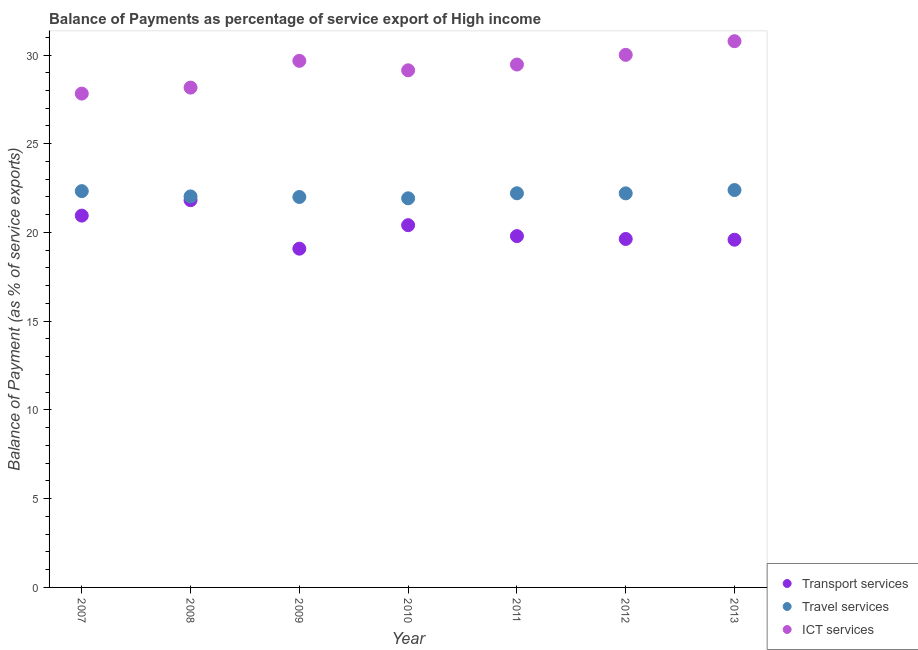Is the number of dotlines equal to the number of legend labels?
Your response must be concise. Yes. What is the balance of payment of travel services in 2008?
Your answer should be very brief. 22.03. Across all years, what is the maximum balance of payment of travel services?
Ensure brevity in your answer.  22.39. Across all years, what is the minimum balance of payment of travel services?
Provide a succinct answer. 21.93. What is the total balance of payment of ict services in the graph?
Offer a very short reply. 205.05. What is the difference between the balance of payment of transport services in 2007 and that in 2008?
Your response must be concise. -0.87. What is the difference between the balance of payment of ict services in 2007 and the balance of payment of travel services in 2013?
Make the answer very short. 5.43. What is the average balance of payment of transport services per year?
Provide a short and direct response. 20.18. In the year 2010, what is the difference between the balance of payment of ict services and balance of payment of travel services?
Provide a short and direct response. 7.21. What is the ratio of the balance of payment of travel services in 2007 to that in 2012?
Your response must be concise. 1.01. What is the difference between the highest and the second highest balance of payment of travel services?
Provide a short and direct response. 0.06. What is the difference between the highest and the lowest balance of payment of ict services?
Give a very brief answer. 2.95. Is the sum of the balance of payment of travel services in 2007 and 2009 greater than the maximum balance of payment of transport services across all years?
Ensure brevity in your answer.  Yes. Does the balance of payment of ict services monotonically increase over the years?
Provide a short and direct response. No. How many dotlines are there?
Provide a succinct answer. 3. How many years are there in the graph?
Make the answer very short. 7. Does the graph contain any zero values?
Keep it short and to the point. No. Does the graph contain grids?
Give a very brief answer. No. How are the legend labels stacked?
Provide a succinct answer. Vertical. What is the title of the graph?
Make the answer very short. Balance of Payments as percentage of service export of High income. What is the label or title of the Y-axis?
Offer a very short reply. Balance of Payment (as % of service exports). What is the Balance of Payment (as % of service exports) of Transport services in 2007?
Your response must be concise. 20.95. What is the Balance of Payment (as % of service exports) of Travel services in 2007?
Your answer should be compact. 22.33. What is the Balance of Payment (as % of service exports) in ICT services in 2007?
Offer a very short reply. 27.83. What is the Balance of Payment (as % of service exports) of Transport services in 2008?
Keep it short and to the point. 21.82. What is the Balance of Payment (as % of service exports) in Travel services in 2008?
Ensure brevity in your answer.  22.03. What is the Balance of Payment (as % of service exports) in ICT services in 2008?
Provide a succinct answer. 28.16. What is the Balance of Payment (as % of service exports) in Transport services in 2009?
Ensure brevity in your answer.  19.09. What is the Balance of Payment (as % of service exports) of Travel services in 2009?
Your answer should be compact. 22. What is the Balance of Payment (as % of service exports) of ICT services in 2009?
Offer a terse response. 29.67. What is the Balance of Payment (as % of service exports) of Transport services in 2010?
Keep it short and to the point. 20.41. What is the Balance of Payment (as % of service exports) in Travel services in 2010?
Your answer should be compact. 21.93. What is the Balance of Payment (as % of service exports) in ICT services in 2010?
Your answer should be very brief. 29.14. What is the Balance of Payment (as % of service exports) of Transport services in 2011?
Ensure brevity in your answer.  19.8. What is the Balance of Payment (as % of service exports) in Travel services in 2011?
Your answer should be very brief. 22.21. What is the Balance of Payment (as % of service exports) in ICT services in 2011?
Your answer should be very brief. 29.46. What is the Balance of Payment (as % of service exports) in Transport services in 2012?
Offer a very short reply. 19.63. What is the Balance of Payment (as % of service exports) of Travel services in 2012?
Your response must be concise. 22.2. What is the Balance of Payment (as % of service exports) of ICT services in 2012?
Your response must be concise. 30.01. What is the Balance of Payment (as % of service exports) in Transport services in 2013?
Make the answer very short. 19.59. What is the Balance of Payment (as % of service exports) in Travel services in 2013?
Your response must be concise. 22.39. What is the Balance of Payment (as % of service exports) of ICT services in 2013?
Your response must be concise. 30.78. Across all years, what is the maximum Balance of Payment (as % of service exports) in Transport services?
Give a very brief answer. 21.82. Across all years, what is the maximum Balance of Payment (as % of service exports) of Travel services?
Give a very brief answer. 22.39. Across all years, what is the maximum Balance of Payment (as % of service exports) of ICT services?
Provide a succinct answer. 30.78. Across all years, what is the minimum Balance of Payment (as % of service exports) in Transport services?
Your answer should be compact. 19.09. Across all years, what is the minimum Balance of Payment (as % of service exports) of Travel services?
Ensure brevity in your answer.  21.93. Across all years, what is the minimum Balance of Payment (as % of service exports) of ICT services?
Keep it short and to the point. 27.83. What is the total Balance of Payment (as % of service exports) of Transport services in the graph?
Offer a terse response. 141.29. What is the total Balance of Payment (as % of service exports) of Travel services in the graph?
Provide a short and direct response. 155.09. What is the total Balance of Payment (as % of service exports) in ICT services in the graph?
Offer a terse response. 205.05. What is the difference between the Balance of Payment (as % of service exports) in Transport services in 2007 and that in 2008?
Provide a short and direct response. -0.87. What is the difference between the Balance of Payment (as % of service exports) of Travel services in 2007 and that in 2008?
Give a very brief answer. 0.3. What is the difference between the Balance of Payment (as % of service exports) in ICT services in 2007 and that in 2008?
Your answer should be compact. -0.34. What is the difference between the Balance of Payment (as % of service exports) of Transport services in 2007 and that in 2009?
Provide a short and direct response. 1.86. What is the difference between the Balance of Payment (as % of service exports) of Travel services in 2007 and that in 2009?
Provide a short and direct response. 0.33. What is the difference between the Balance of Payment (as % of service exports) of ICT services in 2007 and that in 2009?
Offer a very short reply. -1.85. What is the difference between the Balance of Payment (as % of service exports) in Transport services in 2007 and that in 2010?
Make the answer very short. 0.54. What is the difference between the Balance of Payment (as % of service exports) of Travel services in 2007 and that in 2010?
Your response must be concise. 0.4. What is the difference between the Balance of Payment (as % of service exports) of ICT services in 2007 and that in 2010?
Provide a succinct answer. -1.31. What is the difference between the Balance of Payment (as % of service exports) in Transport services in 2007 and that in 2011?
Your answer should be compact. 1.15. What is the difference between the Balance of Payment (as % of service exports) of Travel services in 2007 and that in 2011?
Provide a succinct answer. 0.12. What is the difference between the Balance of Payment (as % of service exports) of ICT services in 2007 and that in 2011?
Provide a succinct answer. -1.64. What is the difference between the Balance of Payment (as % of service exports) of Transport services in 2007 and that in 2012?
Offer a very short reply. 1.32. What is the difference between the Balance of Payment (as % of service exports) of Travel services in 2007 and that in 2012?
Your response must be concise. 0.13. What is the difference between the Balance of Payment (as % of service exports) of ICT services in 2007 and that in 2012?
Ensure brevity in your answer.  -2.18. What is the difference between the Balance of Payment (as % of service exports) of Transport services in 2007 and that in 2013?
Provide a succinct answer. 1.36. What is the difference between the Balance of Payment (as % of service exports) in Travel services in 2007 and that in 2013?
Provide a succinct answer. -0.06. What is the difference between the Balance of Payment (as % of service exports) in ICT services in 2007 and that in 2013?
Provide a succinct answer. -2.95. What is the difference between the Balance of Payment (as % of service exports) of Transport services in 2008 and that in 2009?
Make the answer very short. 2.73. What is the difference between the Balance of Payment (as % of service exports) of Travel services in 2008 and that in 2009?
Your answer should be compact. 0.03. What is the difference between the Balance of Payment (as % of service exports) of ICT services in 2008 and that in 2009?
Offer a very short reply. -1.51. What is the difference between the Balance of Payment (as % of service exports) in Transport services in 2008 and that in 2010?
Offer a very short reply. 1.41. What is the difference between the Balance of Payment (as % of service exports) of Travel services in 2008 and that in 2010?
Make the answer very short. 0.11. What is the difference between the Balance of Payment (as % of service exports) of ICT services in 2008 and that in 2010?
Provide a succinct answer. -0.97. What is the difference between the Balance of Payment (as % of service exports) in Transport services in 2008 and that in 2011?
Provide a short and direct response. 2.02. What is the difference between the Balance of Payment (as % of service exports) of Travel services in 2008 and that in 2011?
Give a very brief answer. -0.18. What is the difference between the Balance of Payment (as % of service exports) of ICT services in 2008 and that in 2011?
Provide a succinct answer. -1.3. What is the difference between the Balance of Payment (as % of service exports) in Transport services in 2008 and that in 2012?
Offer a terse response. 2.18. What is the difference between the Balance of Payment (as % of service exports) of Travel services in 2008 and that in 2012?
Your answer should be compact. -0.17. What is the difference between the Balance of Payment (as % of service exports) of ICT services in 2008 and that in 2012?
Your response must be concise. -1.85. What is the difference between the Balance of Payment (as % of service exports) of Transport services in 2008 and that in 2013?
Make the answer very short. 2.23. What is the difference between the Balance of Payment (as % of service exports) of Travel services in 2008 and that in 2013?
Ensure brevity in your answer.  -0.36. What is the difference between the Balance of Payment (as % of service exports) in ICT services in 2008 and that in 2013?
Provide a short and direct response. -2.61. What is the difference between the Balance of Payment (as % of service exports) in Transport services in 2009 and that in 2010?
Ensure brevity in your answer.  -1.32. What is the difference between the Balance of Payment (as % of service exports) in Travel services in 2009 and that in 2010?
Your response must be concise. 0.07. What is the difference between the Balance of Payment (as % of service exports) in ICT services in 2009 and that in 2010?
Offer a very short reply. 0.53. What is the difference between the Balance of Payment (as % of service exports) in Transport services in 2009 and that in 2011?
Keep it short and to the point. -0.71. What is the difference between the Balance of Payment (as % of service exports) in Travel services in 2009 and that in 2011?
Make the answer very short. -0.21. What is the difference between the Balance of Payment (as % of service exports) in ICT services in 2009 and that in 2011?
Give a very brief answer. 0.21. What is the difference between the Balance of Payment (as % of service exports) in Transport services in 2009 and that in 2012?
Make the answer very short. -0.55. What is the difference between the Balance of Payment (as % of service exports) in Travel services in 2009 and that in 2012?
Offer a very short reply. -0.2. What is the difference between the Balance of Payment (as % of service exports) of ICT services in 2009 and that in 2012?
Provide a succinct answer. -0.34. What is the difference between the Balance of Payment (as % of service exports) of Transport services in 2009 and that in 2013?
Provide a succinct answer. -0.51. What is the difference between the Balance of Payment (as % of service exports) of Travel services in 2009 and that in 2013?
Make the answer very short. -0.39. What is the difference between the Balance of Payment (as % of service exports) of ICT services in 2009 and that in 2013?
Provide a short and direct response. -1.11. What is the difference between the Balance of Payment (as % of service exports) of Transport services in 2010 and that in 2011?
Make the answer very short. 0.62. What is the difference between the Balance of Payment (as % of service exports) in Travel services in 2010 and that in 2011?
Your response must be concise. -0.28. What is the difference between the Balance of Payment (as % of service exports) in ICT services in 2010 and that in 2011?
Your response must be concise. -0.33. What is the difference between the Balance of Payment (as % of service exports) in Transport services in 2010 and that in 2012?
Your answer should be very brief. 0.78. What is the difference between the Balance of Payment (as % of service exports) in Travel services in 2010 and that in 2012?
Make the answer very short. -0.28. What is the difference between the Balance of Payment (as % of service exports) in ICT services in 2010 and that in 2012?
Your answer should be very brief. -0.87. What is the difference between the Balance of Payment (as % of service exports) of Transport services in 2010 and that in 2013?
Your response must be concise. 0.82. What is the difference between the Balance of Payment (as % of service exports) of Travel services in 2010 and that in 2013?
Provide a succinct answer. -0.47. What is the difference between the Balance of Payment (as % of service exports) in ICT services in 2010 and that in 2013?
Keep it short and to the point. -1.64. What is the difference between the Balance of Payment (as % of service exports) in Transport services in 2011 and that in 2012?
Make the answer very short. 0.16. What is the difference between the Balance of Payment (as % of service exports) in Travel services in 2011 and that in 2012?
Your answer should be very brief. 0. What is the difference between the Balance of Payment (as % of service exports) of ICT services in 2011 and that in 2012?
Keep it short and to the point. -0.55. What is the difference between the Balance of Payment (as % of service exports) in Transport services in 2011 and that in 2013?
Your answer should be compact. 0.2. What is the difference between the Balance of Payment (as % of service exports) in Travel services in 2011 and that in 2013?
Your response must be concise. -0.18. What is the difference between the Balance of Payment (as % of service exports) in ICT services in 2011 and that in 2013?
Your response must be concise. -1.31. What is the difference between the Balance of Payment (as % of service exports) in Transport services in 2012 and that in 2013?
Your response must be concise. 0.04. What is the difference between the Balance of Payment (as % of service exports) of Travel services in 2012 and that in 2013?
Offer a very short reply. -0.19. What is the difference between the Balance of Payment (as % of service exports) of ICT services in 2012 and that in 2013?
Provide a succinct answer. -0.77. What is the difference between the Balance of Payment (as % of service exports) of Transport services in 2007 and the Balance of Payment (as % of service exports) of Travel services in 2008?
Your response must be concise. -1.08. What is the difference between the Balance of Payment (as % of service exports) in Transport services in 2007 and the Balance of Payment (as % of service exports) in ICT services in 2008?
Keep it short and to the point. -7.21. What is the difference between the Balance of Payment (as % of service exports) in Travel services in 2007 and the Balance of Payment (as % of service exports) in ICT services in 2008?
Your answer should be compact. -5.83. What is the difference between the Balance of Payment (as % of service exports) in Transport services in 2007 and the Balance of Payment (as % of service exports) in Travel services in 2009?
Your answer should be compact. -1.05. What is the difference between the Balance of Payment (as % of service exports) of Transport services in 2007 and the Balance of Payment (as % of service exports) of ICT services in 2009?
Keep it short and to the point. -8.72. What is the difference between the Balance of Payment (as % of service exports) of Travel services in 2007 and the Balance of Payment (as % of service exports) of ICT services in 2009?
Ensure brevity in your answer.  -7.34. What is the difference between the Balance of Payment (as % of service exports) in Transport services in 2007 and the Balance of Payment (as % of service exports) in Travel services in 2010?
Offer a terse response. -0.97. What is the difference between the Balance of Payment (as % of service exports) in Transport services in 2007 and the Balance of Payment (as % of service exports) in ICT services in 2010?
Provide a short and direct response. -8.19. What is the difference between the Balance of Payment (as % of service exports) in Travel services in 2007 and the Balance of Payment (as % of service exports) in ICT services in 2010?
Ensure brevity in your answer.  -6.81. What is the difference between the Balance of Payment (as % of service exports) of Transport services in 2007 and the Balance of Payment (as % of service exports) of Travel services in 2011?
Offer a terse response. -1.26. What is the difference between the Balance of Payment (as % of service exports) of Transport services in 2007 and the Balance of Payment (as % of service exports) of ICT services in 2011?
Give a very brief answer. -8.51. What is the difference between the Balance of Payment (as % of service exports) in Travel services in 2007 and the Balance of Payment (as % of service exports) in ICT services in 2011?
Your answer should be very brief. -7.13. What is the difference between the Balance of Payment (as % of service exports) in Transport services in 2007 and the Balance of Payment (as % of service exports) in Travel services in 2012?
Your answer should be very brief. -1.25. What is the difference between the Balance of Payment (as % of service exports) of Transport services in 2007 and the Balance of Payment (as % of service exports) of ICT services in 2012?
Provide a short and direct response. -9.06. What is the difference between the Balance of Payment (as % of service exports) of Travel services in 2007 and the Balance of Payment (as % of service exports) of ICT services in 2012?
Provide a short and direct response. -7.68. What is the difference between the Balance of Payment (as % of service exports) of Transport services in 2007 and the Balance of Payment (as % of service exports) of Travel services in 2013?
Keep it short and to the point. -1.44. What is the difference between the Balance of Payment (as % of service exports) in Transport services in 2007 and the Balance of Payment (as % of service exports) in ICT services in 2013?
Offer a very short reply. -9.83. What is the difference between the Balance of Payment (as % of service exports) in Travel services in 2007 and the Balance of Payment (as % of service exports) in ICT services in 2013?
Give a very brief answer. -8.45. What is the difference between the Balance of Payment (as % of service exports) of Transport services in 2008 and the Balance of Payment (as % of service exports) of Travel services in 2009?
Ensure brevity in your answer.  -0.18. What is the difference between the Balance of Payment (as % of service exports) in Transport services in 2008 and the Balance of Payment (as % of service exports) in ICT services in 2009?
Provide a succinct answer. -7.85. What is the difference between the Balance of Payment (as % of service exports) in Travel services in 2008 and the Balance of Payment (as % of service exports) in ICT services in 2009?
Give a very brief answer. -7.64. What is the difference between the Balance of Payment (as % of service exports) of Transport services in 2008 and the Balance of Payment (as % of service exports) of Travel services in 2010?
Make the answer very short. -0.11. What is the difference between the Balance of Payment (as % of service exports) of Transport services in 2008 and the Balance of Payment (as % of service exports) of ICT services in 2010?
Offer a very short reply. -7.32. What is the difference between the Balance of Payment (as % of service exports) in Travel services in 2008 and the Balance of Payment (as % of service exports) in ICT services in 2010?
Provide a short and direct response. -7.11. What is the difference between the Balance of Payment (as % of service exports) of Transport services in 2008 and the Balance of Payment (as % of service exports) of Travel services in 2011?
Your answer should be compact. -0.39. What is the difference between the Balance of Payment (as % of service exports) in Transport services in 2008 and the Balance of Payment (as % of service exports) in ICT services in 2011?
Ensure brevity in your answer.  -7.64. What is the difference between the Balance of Payment (as % of service exports) of Travel services in 2008 and the Balance of Payment (as % of service exports) of ICT services in 2011?
Give a very brief answer. -7.43. What is the difference between the Balance of Payment (as % of service exports) in Transport services in 2008 and the Balance of Payment (as % of service exports) in Travel services in 2012?
Make the answer very short. -0.39. What is the difference between the Balance of Payment (as % of service exports) of Transport services in 2008 and the Balance of Payment (as % of service exports) of ICT services in 2012?
Ensure brevity in your answer.  -8.19. What is the difference between the Balance of Payment (as % of service exports) in Travel services in 2008 and the Balance of Payment (as % of service exports) in ICT services in 2012?
Provide a succinct answer. -7.98. What is the difference between the Balance of Payment (as % of service exports) in Transport services in 2008 and the Balance of Payment (as % of service exports) in Travel services in 2013?
Keep it short and to the point. -0.57. What is the difference between the Balance of Payment (as % of service exports) of Transport services in 2008 and the Balance of Payment (as % of service exports) of ICT services in 2013?
Keep it short and to the point. -8.96. What is the difference between the Balance of Payment (as % of service exports) in Travel services in 2008 and the Balance of Payment (as % of service exports) in ICT services in 2013?
Offer a terse response. -8.75. What is the difference between the Balance of Payment (as % of service exports) of Transport services in 2009 and the Balance of Payment (as % of service exports) of Travel services in 2010?
Provide a succinct answer. -2.84. What is the difference between the Balance of Payment (as % of service exports) in Transport services in 2009 and the Balance of Payment (as % of service exports) in ICT services in 2010?
Your answer should be compact. -10.05. What is the difference between the Balance of Payment (as % of service exports) of Travel services in 2009 and the Balance of Payment (as % of service exports) of ICT services in 2010?
Offer a terse response. -7.14. What is the difference between the Balance of Payment (as % of service exports) of Transport services in 2009 and the Balance of Payment (as % of service exports) of Travel services in 2011?
Give a very brief answer. -3.12. What is the difference between the Balance of Payment (as % of service exports) in Transport services in 2009 and the Balance of Payment (as % of service exports) in ICT services in 2011?
Ensure brevity in your answer.  -10.38. What is the difference between the Balance of Payment (as % of service exports) of Travel services in 2009 and the Balance of Payment (as % of service exports) of ICT services in 2011?
Keep it short and to the point. -7.46. What is the difference between the Balance of Payment (as % of service exports) in Transport services in 2009 and the Balance of Payment (as % of service exports) in Travel services in 2012?
Your response must be concise. -3.12. What is the difference between the Balance of Payment (as % of service exports) of Transport services in 2009 and the Balance of Payment (as % of service exports) of ICT services in 2012?
Give a very brief answer. -10.92. What is the difference between the Balance of Payment (as % of service exports) of Travel services in 2009 and the Balance of Payment (as % of service exports) of ICT services in 2012?
Ensure brevity in your answer.  -8.01. What is the difference between the Balance of Payment (as % of service exports) in Transport services in 2009 and the Balance of Payment (as % of service exports) in Travel services in 2013?
Make the answer very short. -3.3. What is the difference between the Balance of Payment (as % of service exports) of Transport services in 2009 and the Balance of Payment (as % of service exports) of ICT services in 2013?
Your response must be concise. -11.69. What is the difference between the Balance of Payment (as % of service exports) of Travel services in 2009 and the Balance of Payment (as % of service exports) of ICT services in 2013?
Make the answer very short. -8.78. What is the difference between the Balance of Payment (as % of service exports) of Transport services in 2010 and the Balance of Payment (as % of service exports) of Travel services in 2011?
Your response must be concise. -1.8. What is the difference between the Balance of Payment (as % of service exports) of Transport services in 2010 and the Balance of Payment (as % of service exports) of ICT services in 2011?
Make the answer very short. -9.05. What is the difference between the Balance of Payment (as % of service exports) of Travel services in 2010 and the Balance of Payment (as % of service exports) of ICT services in 2011?
Offer a terse response. -7.54. What is the difference between the Balance of Payment (as % of service exports) in Transport services in 2010 and the Balance of Payment (as % of service exports) in Travel services in 2012?
Provide a succinct answer. -1.79. What is the difference between the Balance of Payment (as % of service exports) of Transport services in 2010 and the Balance of Payment (as % of service exports) of ICT services in 2012?
Offer a very short reply. -9.6. What is the difference between the Balance of Payment (as % of service exports) of Travel services in 2010 and the Balance of Payment (as % of service exports) of ICT services in 2012?
Make the answer very short. -8.08. What is the difference between the Balance of Payment (as % of service exports) of Transport services in 2010 and the Balance of Payment (as % of service exports) of Travel services in 2013?
Offer a terse response. -1.98. What is the difference between the Balance of Payment (as % of service exports) of Transport services in 2010 and the Balance of Payment (as % of service exports) of ICT services in 2013?
Your answer should be compact. -10.37. What is the difference between the Balance of Payment (as % of service exports) of Travel services in 2010 and the Balance of Payment (as % of service exports) of ICT services in 2013?
Make the answer very short. -8.85. What is the difference between the Balance of Payment (as % of service exports) of Transport services in 2011 and the Balance of Payment (as % of service exports) of Travel services in 2012?
Your answer should be compact. -2.41. What is the difference between the Balance of Payment (as % of service exports) in Transport services in 2011 and the Balance of Payment (as % of service exports) in ICT services in 2012?
Your answer should be compact. -10.21. What is the difference between the Balance of Payment (as % of service exports) in Travel services in 2011 and the Balance of Payment (as % of service exports) in ICT services in 2012?
Offer a very short reply. -7.8. What is the difference between the Balance of Payment (as % of service exports) of Transport services in 2011 and the Balance of Payment (as % of service exports) of Travel services in 2013?
Give a very brief answer. -2.6. What is the difference between the Balance of Payment (as % of service exports) in Transport services in 2011 and the Balance of Payment (as % of service exports) in ICT services in 2013?
Ensure brevity in your answer.  -10.98. What is the difference between the Balance of Payment (as % of service exports) of Travel services in 2011 and the Balance of Payment (as % of service exports) of ICT services in 2013?
Give a very brief answer. -8.57. What is the difference between the Balance of Payment (as % of service exports) in Transport services in 2012 and the Balance of Payment (as % of service exports) in Travel services in 2013?
Keep it short and to the point. -2.76. What is the difference between the Balance of Payment (as % of service exports) in Transport services in 2012 and the Balance of Payment (as % of service exports) in ICT services in 2013?
Offer a terse response. -11.14. What is the difference between the Balance of Payment (as % of service exports) in Travel services in 2012 and the Balance of Payment (as % of service exports) in ICT services in 2013?
Your response must be concise. -8.57. What is the average Balance of Payment (as % of service exports) of Transport services per year?
Give a very brief answer. 20.18. What is the average Balance of Payment (as % of service exports) of Travel services per year?
Offer a very short reply. 22.16. What is the average Balance of Payment (as % of service exports) in ICT services per year?
Your response must be concise. 29.29. In the year 2007, what is the difference between the Balance of Payment (as % of service exports) in Transport services and Balance of Payment (as % of service exports) in Travel services?
Keep it short and to the point. -1.38. In the year 2007, what is the difference between the Balance of Payment (as % of service exports) in Transport services and Balance of Payment (as % of service exports) in ICT services?
Make the answer very short. -6.88. In the year 2007, what is the difference between the Balance of Payment (as % of service exports) in Travel services and Balance of Payment (as % of service exports) in ICT services?
Your answer should be very brief. -5.5. In the year 2008, what is the difference between the Balance of Payment (as % of service exports) in Transport services and Balance of Payment (as % of service exports) in Travel services?
Give a very brief answer. -0.21. In the year 2008, what is the difference between the Balance of Payment (as % of service exports) in Transport services and Balance of Payment (as % of service exports) in ICT services?
Keep it short and to the point. -6.34. In the year 2008, what is the difference between the Balance of Payment (as % of service exports) in Travel services and Balance of Payment (as % of service exports) in ICT services?
Offer a very short reply. -6.13. In the year 2009, what is the difference between the Balance of Payment (as % of service exports) of Transport services and Balance of Payment (as % of service exports) of Travel services?
Keep it short and to the point. -2.91. In the year 2009, what is the difference between the Balance of Payment (as % of service exports) of Transport services and Balance of Payment (as % of service exports) of ICT services?
Offer a very short reply. -10.58. In the year 2009, what is the difference between the Balance of Payment (as % of service exports) in Travel services and Balance of Payment (as % of service exports) in ICT services?
Make the answer very short. -7.67. In the year 2010, what is the difference between the Balance of Payment (as % of service exports) in Transport services and Balance of Payment (as % of service exports) in Travel services?
Give a very brief answer. -1.51. In the year 2010, what is the difference between the Balance of Payment (as % of service exports) in Transport services and Balance of Payment (as % of service exports) in ICT services?
Your answer should be very brief. -8.73. In the year 2010, what is the difference between the Balance of Payment (as % of service exports) of Travel services and Balance of Payment (as % of service exports) of ICT services?
Give a very brief answer. -7.21. In the year 2011, what is the difference between the Balance of Payment (as % of service exports) of Transport services and Balance of Payment (as % of service exports) of Travel services?
Keep it short and to the point. -2.41. In the year 2011, what is the difference between the Balance of Payment (as % of service exports) in Transport services and Balance of Payment (as % of service exports) in ICT services?
Offer a terse response. -9.67. In the year 2011, what is the difference between the Balance of Payment (as % of service exports) in Travel services and Balance of Payment (as % of service exports) in ICT services?
Ensure brevity in your answer.  -7.25. In the year 2012, what is the difference between the Balance of Payment (as % of service exports) of Transport services and Balance of Payment (as % of service exports) of Travel services?
Offer a very short reply. -2.57. In the year 2012, what is the difference between the Balance of Payment (as % of service exports) in Transport services and Balance of Payment (as % of service exports) in ICT services?
Provide a short and direct response. -10.37. In the year 2012, what is the difference between the Balance of Payment (as % of service exports) in Travel services and Balance of Payment (as % of service exports) in ICT services?
Offer a terse response. -7.8. In the year 2013, what is the difference between the Balance of Payment (as % of service exports) in Transport services and Balance of Payment (as % of service exports) in Travel services?
Your answer should be very brief. -2.8. In the year 2013, what is the difference between the Balance of Payment (as % of service exports) in Transport services and Balance of Payment (as % of service exports) in ICT services?
Make the answer very short. -11.19. In the year 2013, what is the difference between the Balance of Payment (as % of service exports) of Travel services and Balance of Payment (as % of service exports) of ICT services?
Offer a terse response. -8.39. What is the ratio of the Balance of Payment (as % of service exports) of Transport services in 2007 to that in 2008?
Your answer should be very brief. 0.96. What is the ratio of the Balance of Payment (as % of service exports) in Travel services in 2007 to that in 2008?
Your answer should be compact. 1.01. What is the ratio of the Balance of Payment (as % of service exports) in Transport services in 2007 to that in 2009?
Offer a very short reply. 1.1. What is the ratio of the Balance of Payment (as % of service exports) of Travel services in 2007 to that in 2009?
Your answer should be very brief. 1.01. What is the ratio of the Balance of Payment (as % of service exports) in ICT services in 2007 to that in 2009?
Provide a short and direct response. 0.94. What is the ratio of the Balance of Payment (as % of service exports) in Transport services in 2007 to that in 2010?
Provide a succinct answer. 1.03. What is the ratio of the Balance of Payment (as % of service exports) in Travel services in 2007 to that in 2010?
Keep it short and to the point. 1.02. What is the ratio of the Balance of Payment (as % of service exports) of ICT services in 2007 to that in 2010?
Your answer should be compact. 0.95. What is the ratio of the Balance of Payment (as % of service exports) of Transport services in 2007 to that in 2011?
Provide a succinct answer. 1.06. What is the ratio of the Balance of Payment (as % of service exports) of Travel services in 2007 to that in 2011?
Your answer should be very brief. 1.01. What is the ratio of the Balance of Payment (as % of service exports) of ICT services in 2007 to that in 2011?
Your answer should be compact. 0.94. What is the ratio of the Balance of Payment (as % of service exports) of Transport services in 2007 to that in 2012?
Keep it short and to the point. 1.07. What is the ratio of the Balance of Payment (as % of service exports) in Travel services in 2007 to that in 2012?
Your answer should be compact. 1.01. What is the ratio of the Balance of Payment (as % of service exports) of ICT services in 2007 to that in 2012?
Make the answer very short. 0.93. What is the ratio of the Balance of Payment (as % of service exports) of Transport services in 2007 to that in 2013?
Ensure brevity in your answer.  1.07. What is the ratio of the Balance of Payment (as % of service exports) in Travel services in 2007 to that in 2013?
Offer a very short reply. 1. What is the ratio of the Balance of Payment (as % of service exports) of ICT services in 2007 to that in 2013?
Offer a very short reply. 0.9. What is the ratio of the Balance of Payment (as % of service exports) of Transport services in 2008 to that in 2009?
Your answer should be very brief. 1.14. What is the ratio of the Balance of Payment (as % of service exports) in Travel services in 2008 to that in 2009?
Offer a terse response. 1. What is the ratio of the Balance of Payment (as % of service exports) in ICT services in 2008 to that in 2009?
Keep it short and to the point. 0.95. What is the ratio of the Balance of Payment (as % of service exports) of Transport services in 2008 to that in 2010?
Ensure brevity in your answer.  1.07. What is the ratio of the Balance of Payment (as % of service exports) of Travel services in 2008 to that in 2010?
Keep it short and to the point. 1. What is the ratio of the Balance of Payment (as % of service exports) in ICT services in 2008 to that in 2010?
Provide a succinct answer. 0.97. What is the ratio of the Balance of Payment (as % of service exports) of Transport services in 2008 to that in 2011?
Your answer should be very brief. 1.1. What is the ratio of the Balance of Payment (as % of service exports) of Travel services in 2008 to that in 2011?
Your response must be concise. 0.99. What is the ratio of the Balance of Payment (as % of service exports) of ICT services in 2008 to that in 2011?
Keep it short and to the point. 0.96. What is the ratio of the Balance of Payment (as % of service exports) in Transport services in 2008 to that in 2012?
Ensure brevity in your answer.  1.11. What is the ratio of the Balance of Payment (as % of service exports) of ICT services in 2008 to that in 2012?
Keep it short and to the point. 0.94. What is the ratio of the Balance of Payment (as % of service exports) in Transport services in 2008 to that in 2013?
Your answer should be compact. 1.11. What is the ratio of the Balance of Payment (as % of service exports) of Travel services in 2008 to that in 2013?
Your answer should be very brief. 0.98. What is the ratio of the Balance of Payment (as % of service exports) of ICT services in 2008 to that in 2013?
Keep it short and to the point. 0.92. What is the ratio of the Balance of Payment (as % of service exports) in Transport services in 2009 to that in 2010?
Offer a very short reply. 0.94. What is the ratio of the Balance of Payment (as % of service exports) in ICT services in 2009 to that in 2010?
Keep it short and to the point. 1.02. What is the ratio of the Balance of Payment (as % of service exports) of Transport services in 2009 to that in 2011?
Ensure brevity in your answer.  0.96. What is the ratio of the Balance of Payment (as % of service exports) in Travel services in 2009 to that in 2011?
Offer a very short reply. 0.99. What is the ratio of the Balance of Payment (as % of service exports) in ICT services in 2009 to that in 2011?
Your answer should be very brief. 1.01. What is the ratio of the Balance of Payment (as % of service exports) of Transport services in 2009 to that in 2012?
Offer a terse response. 0.97. What is the ratio of the Balance of Payment (as % of service exports) in ICT services in 2009 to that in 2012?
Provide a short and direct response. 0.99. What is the ratio of the Balance of Payment (as % of service exports) in Transport services in 2009 to that in 2013?
Offer a terse response. 0.97. What is the ratio of the Balance of Payment (as % of service exports) in Travel services in 2009 to that in 2013?
Give a very brief answer. 0.98. What is the ratio of the Balance of Payment (as % of service exports) in Transport services in 2010 to that in 2011?
Provide a succinct answer. 1.03. What is the ratio of the Balance of Payment (as % of service exports) of Travel services in 2010 to that in 2011?
Give a very brief answer. 0.99. What is the ratio of the Balance of Payment (as % of service exports) in ICT services in 2010 to that in 2011?
Your answer should be compact. 0.99. What is the ratio of the Balance of Payment (as % of service exports) in Transport services in 2010 to that in 2012?
Make the answer very short. 1.04. What is the ratio of the Balance of Payment (as % of service exports) in Travel services in 2010 to that in 2012?
Offer a terse response. 0.99. What is the ratio of the Balance of Payment (as % of service exports) of ICT services in 2010 to that in 2012?
Your answer should be very brief. 0.97. What is the ratio of the Balance of Payment (as % of service exports) in Transport services in 2010 to that in 2013?
Your answer should be compact. 1.04. What is the ratio of the Balance of Payment (as % of service exports) of Travel services in 2010 to that in 2013?
Your answer should be very brief. 0.98. What is the ratio of the Balance of Payment (as % of service exports) of ICT services in 2010 to that in 2013?
Offer a terse response. 0.95. What is the ratio of the Balance of Payment (as % of service exports) in Transport services in 2011 to that in 2012?
Your response must be concise. 1.01. What is the ratio of the Balance of Payment (as % of service exports) in ICT services in 2011 to that in 2012?
Your answer should be very brief. 0.98. What is the ratio of the Balance of Payment (as % of service exports) of Transport services in 2011 to that in 2013?
Keep it short and to the point. 1.01. What is the ratio of the Balance of Payment (as % of service exports) in Travel services in 2011 to that in 2013?
Provide a succinct answer. 0.99. What is the ratio of the Balance of Payment (as % of service exports) in ICT services in 2011 to that in 2013?
Your answer should be compact. 0.96. What is the ratio of the Balance of Payment (as % of service exports) of Transport services in 2012 to that in 2013?
Your response must be concise. 1. What is the ratio of the Balance of Payment (as % of service exports) in Travel services in 2012 to that in 2013?
Provide a succinct answer. 0.99. What is the ratio of the Balance of Payment (as % of service exports) in ICT services in 2012 to that in 2013?
Provide a short and direct response. 0.97. What is the difference between the highest and the second highest Balance of Payment (as % of service exports) in Transport services?
Your answer should be very brief. 0.87. What is the difference between the highest and the second highest Balance of Payment (as % of service exports) of Travel services?
Your answer should be compact. 0.06. What is the difference between the highest and the second highest Balance of Payment (as % of service exports) in ICT services?
Your answer should be compact. 0.77. What is the difference between the highest and the lowest Balance of Payment (as % of service exports) of Transport services?
Offer a terse response. 2.73. What is the difference between the highest and the lowest Balance of Payment (as % of service exports) in Travel services?
Provide a short and direct response. 0.47. What is the difference between the highest and the lowest Balance of Payment (as % of service exports) of ICT services?
Keep it short and to the point. 2.95. 